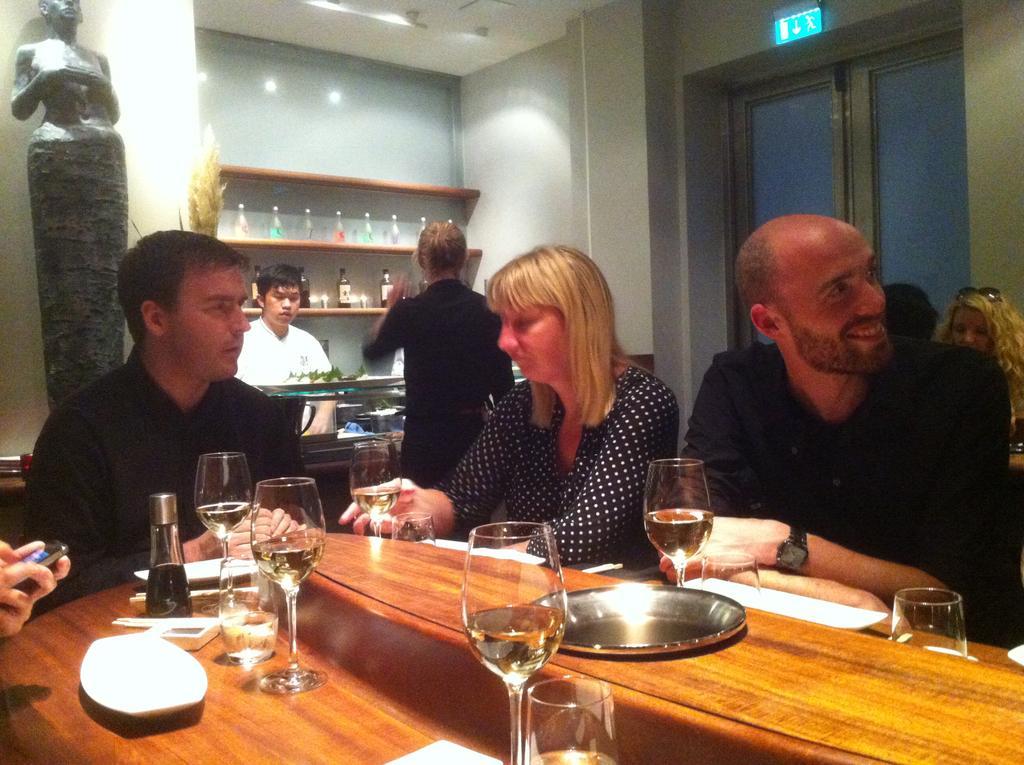Please provide a concise description of this image. In the image we can see three persons were sitting around the table. On table there is a plate,tissue paper,bottle and wine glasses. In the background there is a wall,shelf,statue,window,sign board,wine bottles and few persons were standing and sitting. 